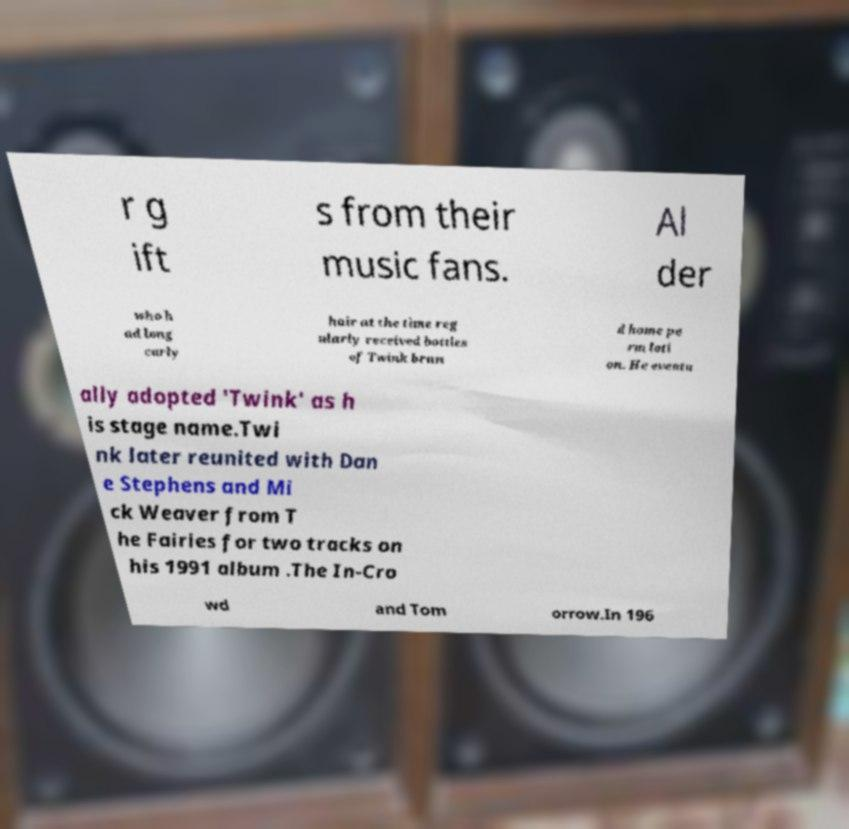There's text embedded in this image that I need extracted. Can you transcribe it verbatim? r g ift s from their music fans. Al der who h ad long curly hair at the time reg ularly received bottles of Twink bran d home pe rm loti on. He eventu ally adopted 'Twink' as h is stage name.Twi nk later reunited with Dan e Stephens and Mi ck Weaver from T he Fairies for two tracks on his 1991 album .The In-Cro wd and Tom orrow.In 196 